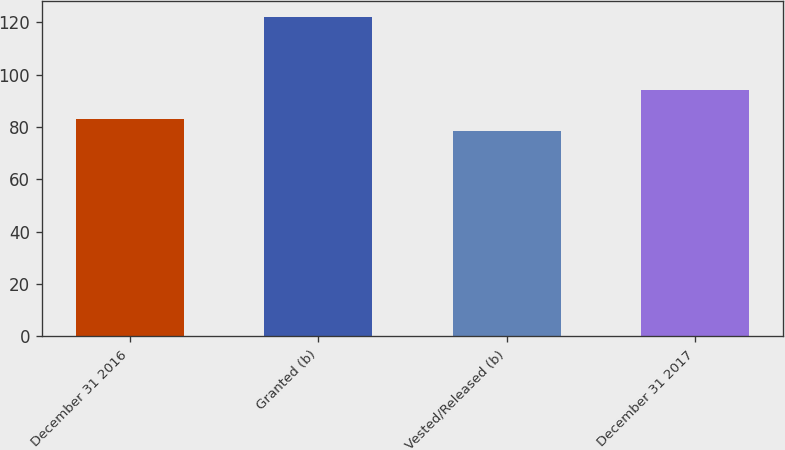<chart> <loc_0><loc_0><loc_500><loc_500><bar_chart><fcel>December 31 2016<fcel>Granted (b)<fcel>Vested/Released (b)<fcel>December 31 2017<nl><fcel>83.03<fcel>122.13<fcel>78.69<fcel>94.29<nl></chart> 